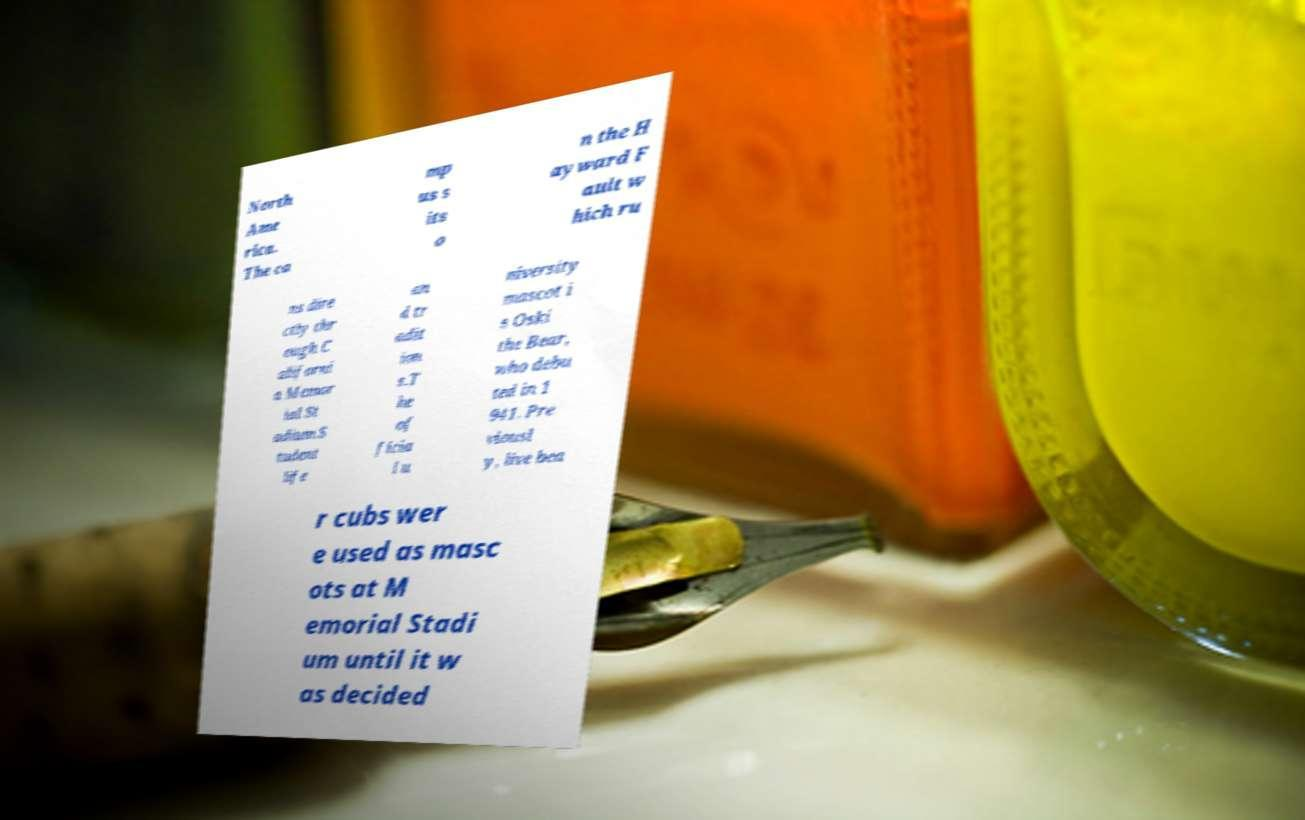Can you read and provide the text displayed in the image?This photo seems to have some interesting text. Can you extract and type it out for me? North Ame rica. The ca mp us s its o n the H ayward F ault w hich ru ns dire ctly thr ough C aliforni a Memor ial St adium.S tudent life an d tr adit ion s.T he of ficia l u niversity mascot i s Oski the Bear, who debu ted in 1 941. Pre viousl y, live bea r cubs wer e used as masc ots at M emorial Stadi um until it w as decided 